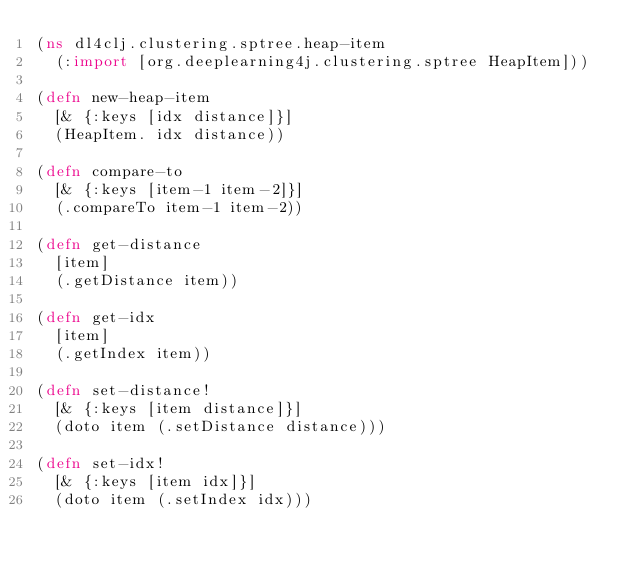Convert code to text. <code><loc_0><loc_0><loc_500><loc_500><_Clojure_>(ns dl4clj.clustering.sptree.heap-item
  (:import [org.deeplearning4j.clustering.sptree HeapItem]))

(defn new-heap-item
  [& {:keys [idx distance]}]
  (HeapItem. idx distance))

(defn compare-to
  [& {:keys [item-1 item-2]}]
  (.compareTo item-1 item-2))

(defn get-distance
  [item]
  (.getDistance item))

(defn get-idx
  [item]
  (.getIndex item))

(defn set-distance!
  [& {:keys [item distance]}]
  (doto item (.setDistance distance)))

(defn set-idx!
  [& {:keys [item idx]}]
  (doto item (.setIndex idx)))
</code> 